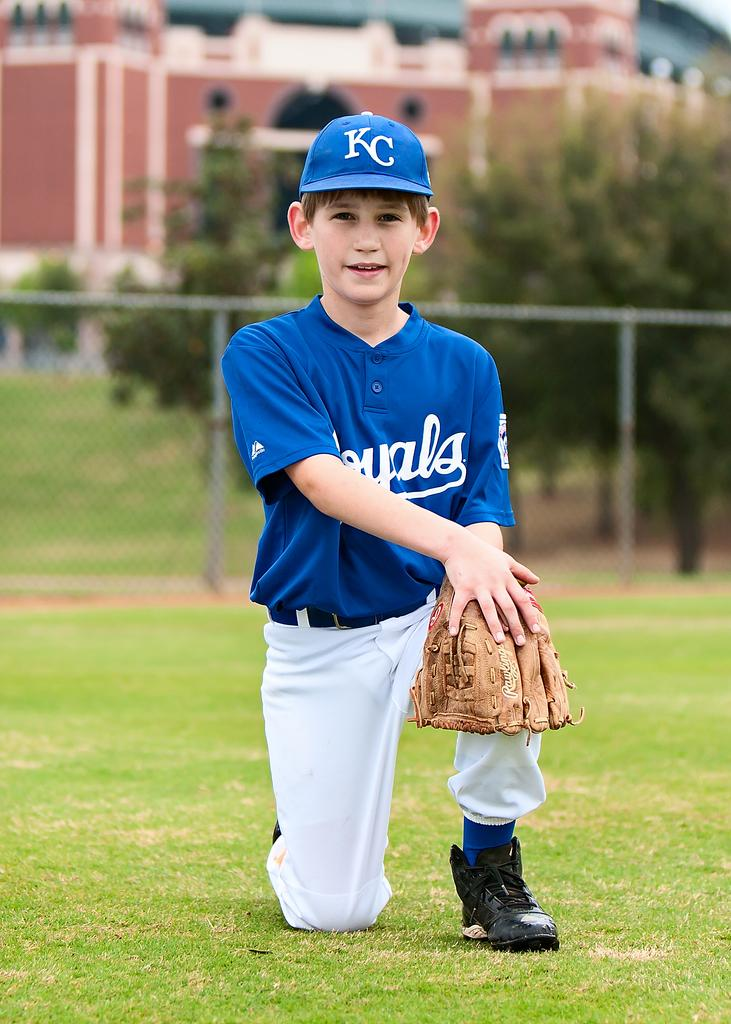<image>
Write a terse but informative summary of the picture. A kid in a baseball uniform with 'KC' on their hat. 